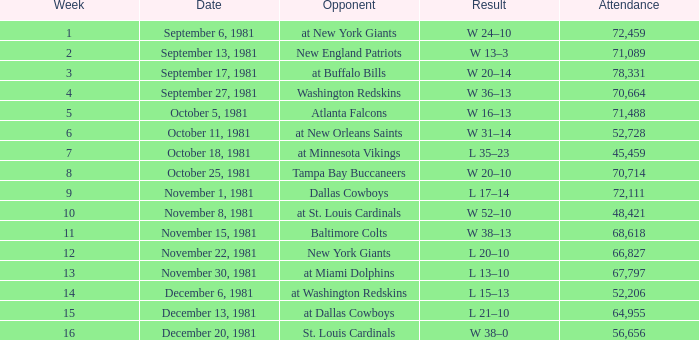What is the turnout, when the rival is the tampa bay buccaneers? 70714.0. Write the full table. {'header': ['Week', 'Date', 'Opponent', 'Result', 'Attendance'], 'rows': [['1', 'September 6, 1981', 'at New York Giants', 'W 24–10', '72,459'], ['2', 'September 13, 1981', 'New England Patriots', 'W 13–3', '71,089'], ['3', 'September 17, 1981', 'at Buffalo Bills', 'W 20–14', '78,331'], ['4', 'September 27, 1981', 'Washington Redskins', 'W 36–13', '70,664'], ['5', 'October 5, 1981', 'Atlanta Falcons', 'W 16–13', '71,488'], ['6', 'October 11, 1981', 'at New Orleans Saints', 'W 31–14', '52,728'], ['7', 'October 18, 1981', 'at Minnesota Vikings', 'L 35–23', '45,459'], ['8', 'October 25, 1981', 'Tampa Bay Buccaneers', 'W 20–10', '70,714'], ['9', 'November 1, 1981', 'Dallas Cowboys', 'L 17–14', '72,111'], ['10', 'November 8, 1981', 'at St. Louis Cardinals', 'W 52–10', '48,421'], ['11', 'November 15, 1981', 'Baltimore Colts', 'W 38–13', '68,618'], ['12', 'November 22, 1981', 'New York Giants', 'L 20–10', '66,827'], ['13', 'November 30, 1981', 'at Miami Dolphins', 'L 13–10', '67,797'], ['14', 'December 6, 1981', 'at Washington Redskins', 'L 15–13', '52,206'], ['15', 'December 13, 1981', 'at Dallas Cowboys', 'L 21–10', '64,955'], ['16', 'December 20, 1981', 'St. Louis Cardinals', 'W 38–0', '56,656']]} 